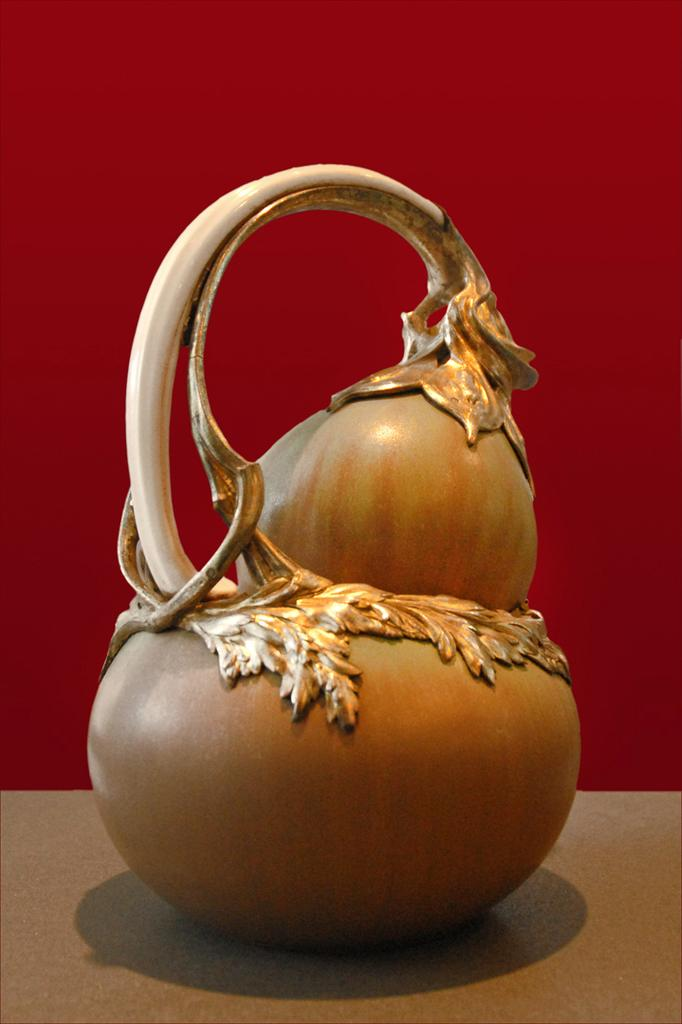What type of object is present in the image that resembles a vegetable? There is a metal object in the image that resembles a vegetable. What color is the background of the image? The background of the image is red in color. What type of silverware is visible in the image? There is no silverware present in the image; it features a metal object that resembles a vegetable. What type of order is being processed in the image? There is no indication of an order being processed in the image. 